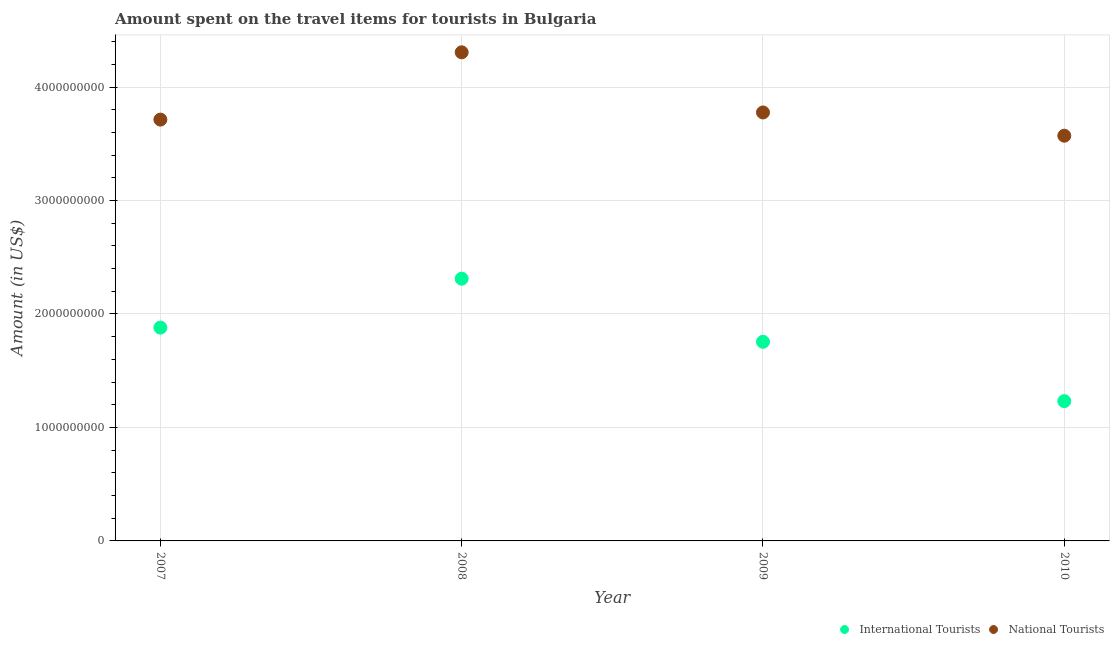How many different coloured dotlines are there?
Offer a very short reply. 2. What is the amount spent on travel items of international tourists in 2007?
Keep it short and to the point. 1.88e+09. Across all years, what is the maximum amount spent on travel items of international tourists?
Your response must be concise. 2.31e+09. Across all years, what is the minimum amount spent on travel items of international tourists?
Provide a short and direct response. 1.23e+09. What is the total amount spent on travel items of international tourists in the graph?
Keep it short and to the point. 7.18e+09. What is the difference between the amount spent on travel items of international tourists in 2007 and that in 2009?
Provide a short and direct response. 1.25e+08. What is the difference between the amount spent on travel items of national tourists in 2007 and the amount spent on travel items of international tourists in 2008?
Give a very brief answer. 1.40e+09. What is the average amount spent on travel items of national tourists per year?
Provide a succinct answer. 3.84e+09. In the year 2010, what is the difference between the amount spent on travel items of national tourists and amount spent on travel items of international tourists?
Offer a terse response. 2.34e+09. What is the ratio of the amount spent on travel items of international tourists in 2009 to that in 2010?
Give a very brief answer. 1.42. Is the amount spent on travel items of international tourists in 2008 less than that in 2010?
Ensure brevity in your answer.  No. Is the difference between the amount spent on travel items of international tourists in 2007 and 2009 greater than the difference between the amount spent on travel items of national tourists in 2007 and 2009?
Ensure brevity in your answer.  Yes. What is the difference between the highest and the second highest amount spent on travel items of national tourists?
Offer a very short reply. 5.30e+08. What is the difference between the highest and the lowest amount spent on travel items of international tourists?
Make the answer very short. 1.08e+09. Is the amount spent on travel items of international tourists strictly less than the amount spent on travel items of national tourists over the years?
Ensure brevity in your answer.  Yes. How many years are there in the graph?
Provide a succinct answer. 4. Are the values on the major ticks of Y-axis written in scientific E-notation?
Your answer should be very brief. No. How many legend labels are there?
Provide a succinct answer. 2. How are the legend labels stacked?
Ensure brevity in your answer.  Horizontal. What is the title of the graph?
Provide a short and direct response. Amount spent on the travel items for tourists in Bulgaria. Does "Commercial service exports" appear as one of the legend labels in the graph?
Make the answer very short. No. What is the label or title of the Y-axis?
Your answer should be compact. Amount (in US$). What is the Amount (in US$) of International Tourists in 2007?
Provide a succinct answer. 1.88e+09. What is the Amount (in US$) of National Tourists in 2007?
Give a very brief answer. 3.71e+09. What is the Amount (in US$) in International Tourists in 2008?
Your answer should be very brief. 2.31e+09. What is the Amount (in US$) in National Tourists in 2008?
Offer a very short reply. 4.31e+09. What is the Amount (in US$) of International Tourists in 2009?
Offer a very short reply. 1.76e+09. What is the Amount (in US$) in National Tourists in 2009?
Offer a terse response. 3.78e+09. What is the Amount (in US$) in International Tourists in 2010?
Provide a short and direct response. 1.23e+09. What is the Amount (in US$) in National Tourists in 2010?
Your answer should be very brief. 3.57e+09. Across all years, what is the maximum Amount (in US$) in International Tourists?
Ensure brevity in your answer.  2.31e+09. Across all years, what is the maximum Amount (in US$) in National Tourists?
Your response must be concise. 4.31e+09. Across all years, what is the minimum Amount (in US$) of International Tourists?
Provide a short and direct response. 1.23e+09. Across all years, what is the minimum Amount (in US$) of National Tourists?
Offer a terse response. 3.57e+09. What is the total Amount (in US$) in International Tourists in the graph?
Your answer should be compact. 7.18e+09. What is the total Amount (in US$) of National Tourists in the graph?
Your answer should be compact. 1.54e+1. What is the difference between the Amount (in US$) in International Tourists in 2007 and that in 2008?
Your response must be concise. -4.31e+08. What is the difference between the Amount (in US$) in National Tourists in 2007 and that in 2008?
Offer a terse response. -5.93e+08. What is the difference between the Amount (in US$) of International Tourists in 2007 and that in 2009?
Your answer should be very brief. 1.25e+08. What is the difference between the Amount (in US$) of National Tourists in 2007 and that in 2009?
Your answer should be very brief. -6.30e+07. What is the difference between the Amount (in US$) of International Tourists in 2007 and that in 2010?
Provide a short and direct response. 6.48e+08. What is the difference between the Amount (in US$) in National Tourists in 2007 and that in 2010?
Your answer should be very brief. 1.42e+08. What is the difference between the Amount (in US$) of International Tourists in 2008 and that in 2009?
Ensure brevity in your answer.  5.56e+08. What is the difference between the Amount (in US$) of National Tourists in 2008 and that in 2009?
Your answer should be very brief. 5.30e+08. What is the difference between the Amount (in US$) in International Tourists in 2008 and that in 2010?
Your response must be concise. 1.08e+09. What is the difference between the Amount (in US$) in National Tourists in 2008 and that in 2010?
Offer a terse response. 7.35e+08. What is the difference between the Amount (in US$) of International Tourists in 2009 and that in 2010?
Your answer should be compact. 5.23e+08. What is the difference between the Amount (in US$) of National Tourists in 2009 and that in 2010?
Offer a terse response. 2.05e+08. What is the difference between the Amount (in US$) in International Tourists in 2007 and the Amount (in US$) in National Tourists in 2008?
Your answer should be compact. -2.43e+09. What is the difference between the Amount (in US$) in International Tourists in 2007 and the Amount (in US$) in National Tourists in 2009?
Offer a very short reply. -1.90e+09. What is the difference between the Amount (in US$) in International Tourists in 2007 and the Amount (in US$) in National Tourists in 2010?
Give a very brief answer. -1.69e+09. What is the difference between the Amount (in US$) in International Tourists in 2008 and the Amount (in US$) in National Tourists in 2009?
Your answer should be compact. -1.46e+09. What is the difference between the Amount (in US$) of International Tourists in 2008 and the Amount (in US$) of National Tourists in 2010?
Give a very brief answer. -1.26e+09. What is the difference between the Amount (in US$) in International Tourists in 2009 and the Amount (in US$) in National Tourists in 2010?
Your answer should be compact. -1.82e+09. What is the average Amount (in US$) of International Tourists per year?
Provide a short and direct response. 1.79e+09. What is the average Amount (in US$) in National Tourists per year?
Make the answer very short. 3.84e+09. In the year 2007, what is the difference between the Amount (in US$) of International Tourists and Amount (in US$) of National Tourists?
Your response must be concise. -1.83e+09. In the year 2008, what is the difference between the Amount (in US$) in International Tourists and Amount (in US$) in National Tourists?
Give a very brief answer. -2.00e+09. In the year 2009, what is the difference between the Amount (in US$) of International Tourists and Amount (in US$) of National Tourists?
Provide a short and direct response. -2.02e+09. In the year 2010, what is the difference between the Amount (in US$) in International Tourists and Amount (in US$) in National Tourists?
Ensure brevity in your answer.  -2.34e+09. What is the ratio of the Amount (in US$) in International Tourists in 2007 to that in 2008?
Your response must be concise. 0.81. What is the ratio of the Amount (in US$) of National Tourists in 2007 to that in 2008?
Your response must be concise. 0.86. What is the ratio of the Amount (in US$) in International Tourists in 2007 to that in 2009?
Keep it short and to the point. 1.07. What is the ratio of the Amount (in US$) of National Tourists in 2007 to that in 2009?
Offer a very short reply. 0.98. What is the ratio of the Amount (in US$) of International Tourists in 2007 to that in 2010?
Your response must be concise. 1.53. What is the ratio of the Amount (in US$) in National Tourists in 2007 to that in 2010?
Your answer should be compact. 1.04. What is the ratio of the Amount (in US$) in International Tourists in 2008 to that in 2009?
Your answer should be very brief. 1.32. What is the ratio of the Amount (in US$) of National Tourists in 2008 to that in 2009?
Offer a very short reply. 1.14. What is the ratio of the Amount (in US$) in International Tourists in 2008 to that in 2010?
Provide a short and direct response. 1.88. What is the ratio of the Amount (in US$) in National Tourists in 2008 to that in 2010?
Make the answer very short. 1.21. What is the ratio of the Amount (in US$) of International Tourists in 2009 to that in 2010?
Your answer should be compact. 1.42. What is the ratio of the Amount (in US$) in National Tourists in 2009 to that in 2010?
Your response must be concise. 1.06. What is the difference between the highest and the second highest Amount (in US$) of International Tourists?
Offer a very short reply. 4.31e+08. What is the difference between the highest and the second highest Amount (in US$) in National Tourists?
Provide a succinct answer. 5.30e+08. What is the difference between the highest and the lowest Amount (in US$) in International Tourists?
Your answer should be compact. 1.08e+09. What is the difference between the highest and the lowest Amount (in US$) of National Tourists?
Provide a succinct answer. 7.35e+08. 